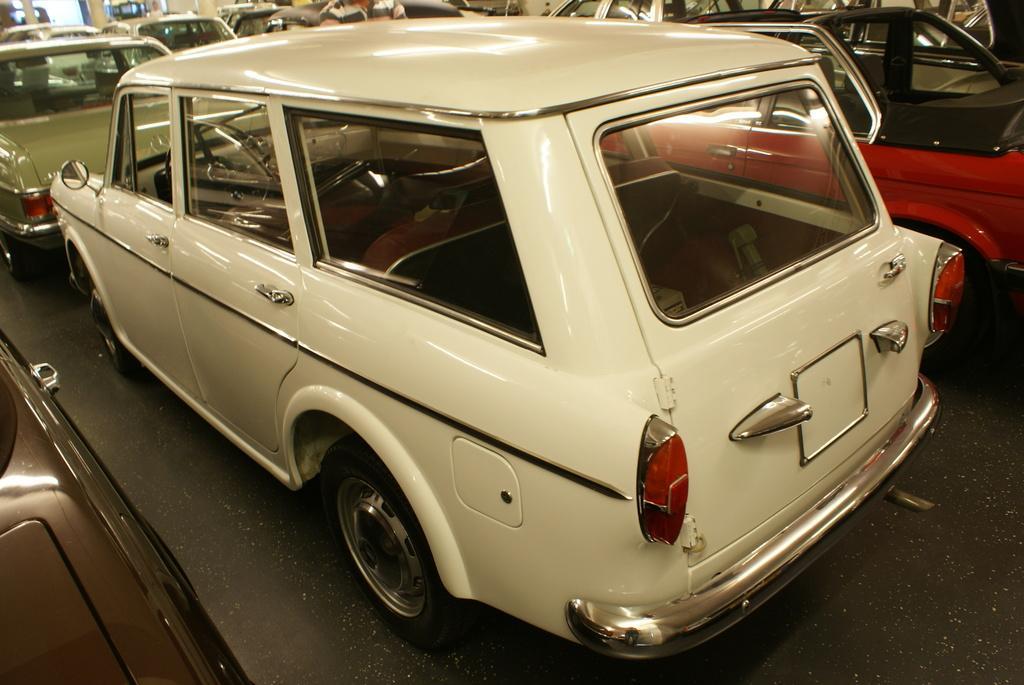Can you describe this image briefly? This image is taken in a parking area. In the middle of the image there is a car on the floor which is in the white color. There are many cars in this image. In the bottom of the image there is a floor. 